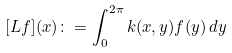<formula> <loc_0><loc_0><loc_500><loc_500>[ L f ] ( x ) \colon = \int _ { 0 } ^ { 2 \pi } k ( x , y ) f ( y ) \, d y</formula> 